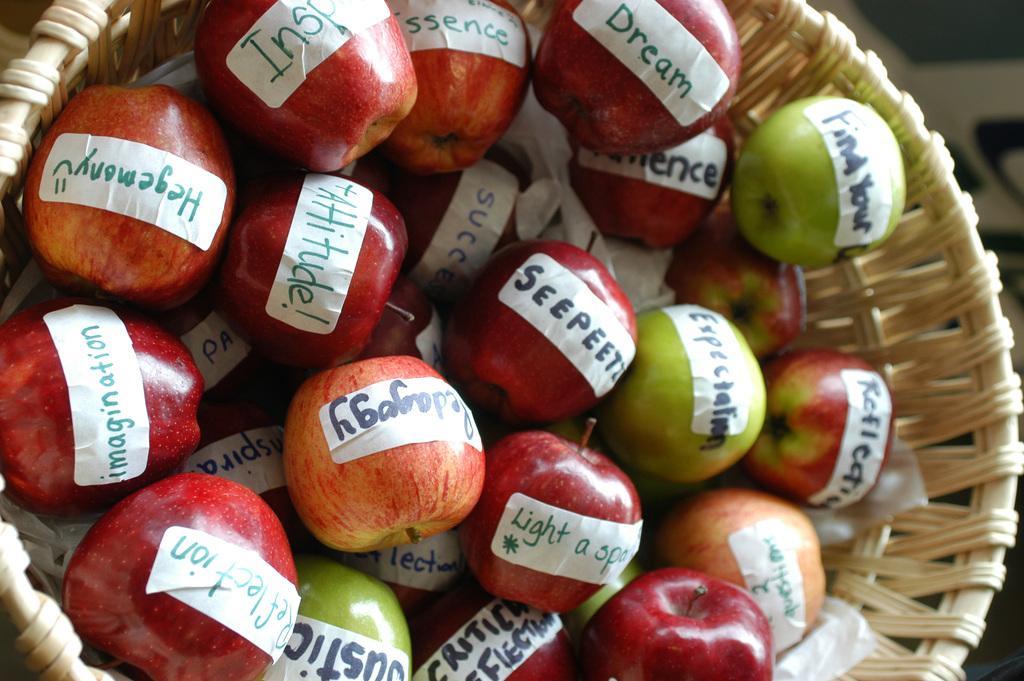In one or two sentences, can you explain what this image depicts? These are the apples in a basket. 